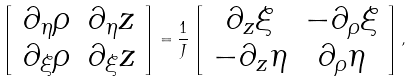<formula> <loc_0><loc_0><loc_500><loc_500>\left [ \begin{array} { c c } \partial _ { \eta } \rho & \partial _ { \eta } z \\ \partial _ { \xi } \rho & \partial _ { \xi } z \end{array} \right ] = \frac { 1 } { J } \left [ \begin{array} { c c } \partial _ { z } \xi & - \partial _ { \rho } \xi \\ - \partial _ { z } \eta & \partial _ { \rho } \eta \end{array} \right ] ,</formula> 